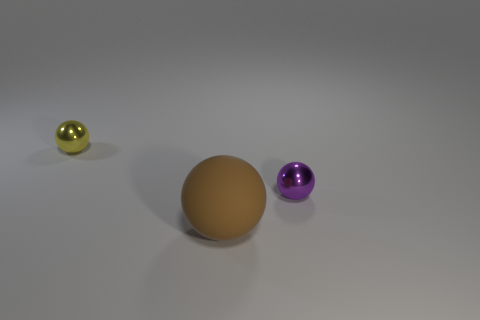Subtract all tiny metal balls. How many balls are left? 1 Add 1 large cyan blocks. How many objects exist? 4 Subtract 0 blue blocks. How many objects are left? 3 Subtract 1 spheres. How many spheres are left? 2 Subtract all blue balls. Subtract all blue cylinders. How many balls are left? 3 Subtract all cyan blocks. How many brown spheres are left? 1 Subtract all green blocks. Subtract all tiny purple balls. How many objects are left? 2 Add 3 yellow metallic objects. How many yellow metallic objects are left? 4 Add 1 small brown metallic cubes. How many small brown metallic cubes exist? 1 Subtract all brown balls. How many balls are left? 2 